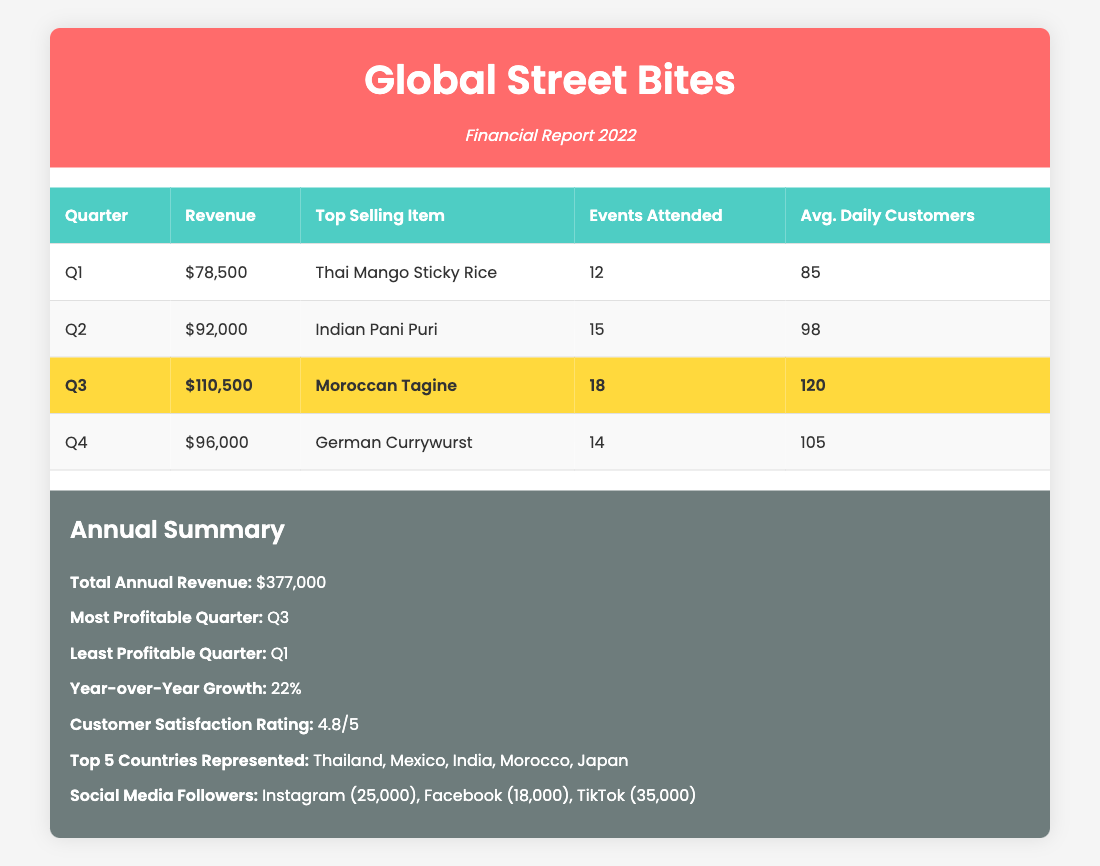What was the total revenue for Q2? The table indicates that the revenue for Q2 is specified directly in the "Revenue" column. Referring to the corresponding row for Q2, we find the revenue listed as $92,000.
Answer: $92,000 Which quarter had the highest average daily customers? We can assess the average daily customers listed for each quarter. Q1 has 85, Q2 has 98, Q3 has 120, and Q4 has 105. Comparing these values, Q3 has the highest average daily customers at 120.
Answer: Q3 Is it true that Indian Pani Puri was the top-selling item in Q2? By examining the "Top Selling Item" for Q2 in the table, we see that Indian Pani Puri is indeed listed as the top-selling item, so this statement is true.
Answer: True What is the revenue growth from Q1 to Q4? To find the revenue growth between Q1 and Q4, we subtract Q1's revenue ($78,500) from Q4's revenue ($96,000): $96,000 - $78,500 = $17,500. Thus, the revenue growth from Q1 to Q4 is $17,500.
Answer: $17,500 Which quarter had the least number of events attended? Looking at the "Events Attended" column, Q1 has 12 events, Q2 has 15 events, Q3 has 18 events, and Q4 has 14 events. The fewest events attended is in Q1 with 12.
Answer: Q1 What were the total units sold in Q3? In order to find the total units sold in Q3, we need to sum the units sold for each top-selling item. The table lists Moroccan Tagine with 1800, Brazilian Acarajé with 1350, and Korean Bibimbap with 1200. Adding these gives us: 1800 + 1350 + 1200 = 4350 units sold in Q3.
Answer: 4350 Did the revenue in Q3 exceed $100,000? Looking at the revenue for Q3 in the table, it is listed as $110,500, which clearly exceeds $100,000, making this statement true.
Answer: True What was the average revenue for the four quarters? To find the average revenue across the four quarters, we first sum the revenues of all quarters: $78,500 + $92,000 + $110,500 + $96,000 = $377,000. Then, we divide this total by 4: $377,000 / 4 = $94,250. Therefore, the average revenue for the quarters is $94,250.
Answer: $94,250 